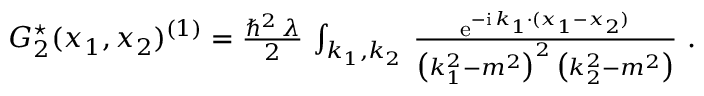Convert formula to latex. <formula><loc_0><loc_0><loc_500><loc_500>\begin{array} { r } { G _ { 2 } ^ { ^ { * } } ( x _ { 1 } , x _ { 2 } ) ^ { ( 1 ) } = \frac { \hbar { ^ } { 2 } \, \lambda } 2 \, \int _ { k _ { 1 } , k _ { 2 } } \, \frac { { e } ^ { - { i } \, k _ { 1 } \cdot ( x _ { 1 } - x _ { 2 } ) } } { \left ( k _ { 1 } ^ { 2 } - m ^ { 2 } \right ) ^ { 2 } \, \left ( k _ { 2 } ^ { 2 } - m ^ { 2 } \right ) } \ . } \end{array}</formula> 